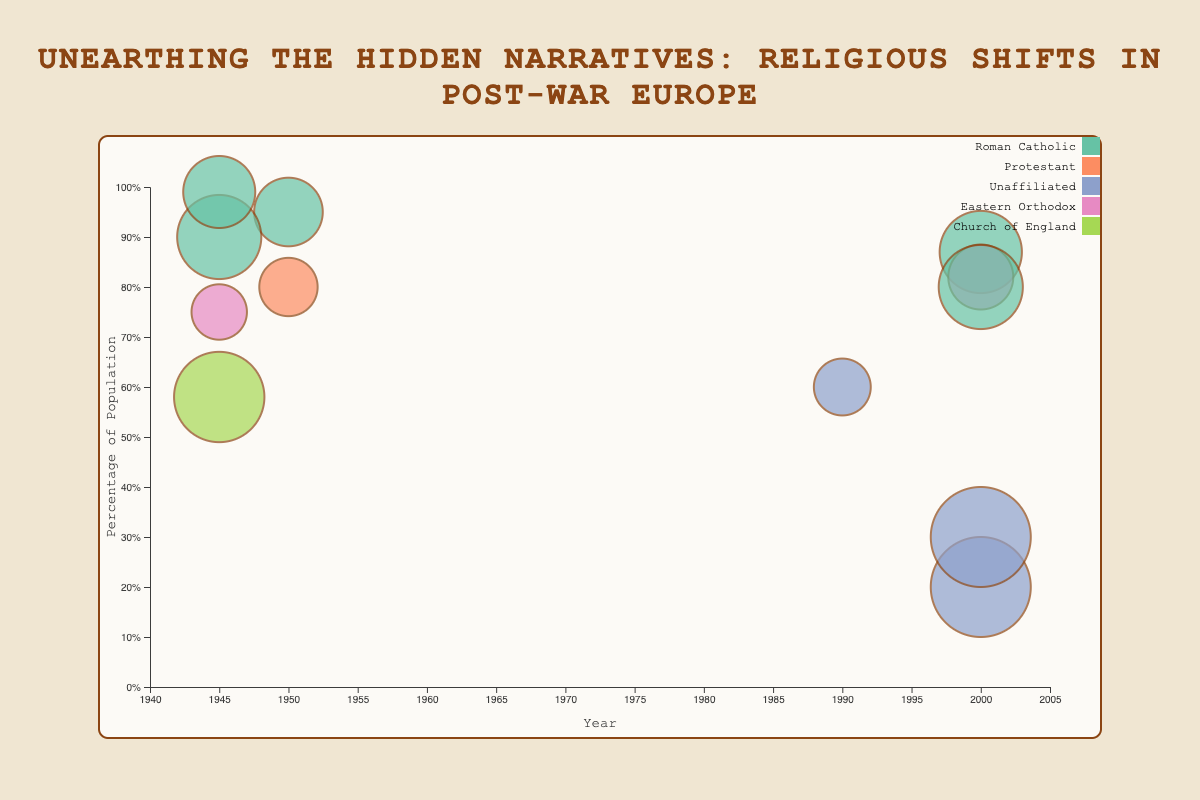What is the general trend in religious affiliation for East Germany between 1950 and 1990? Examine the bubble positions for East Germany in 1950 and 1990. In 1950, a significant Protestant population is represented by a large bubble at 80%. By 1990, a majority of the population is unaffiliated, as depicted by a large bubble at 60%. The trend shows a movement away from Protestantism towards unaffiliation.
Answer: Movement towards unaffiliation How did the percentage of Roman Catholics in Poland change from 1950 to 2000? Compare the vertical position of Poland’s bubbles for 1950 and 2000. In 1950, the bubble is positioned at around 95%, while in 2000, the bubble is positioned at around 87%. Subtracting these, the percentage decreased by 8%.
Answer: Decreased by 8% Which country experienced the highest increase in the population percentage of people unaffiliated with any religion by 2000? Identify countries with unaffiliated bubbles around 2000. Compare the percentages for East Germany and the United Kingdom. In the United Kingdom, the increase from 0% in 1945 to 20% in 2000 is noted, but in East Germany, it increased from 0% to 60%. Thus, East Germany shows a larger increase of 60%.
Answer: East Germany How does the religious affiliation change in France compare to that in Spain between 1945 and 2000? Identify the bubbles representing France and Spain. France shows a shift from 90% Roman Catholic in 1945 to 30% unaffiliated in 2000, a decrease of 60%. Spain shows a decrease from 99% Roman Catholic in 1945 to 80% in 2000. Thus, France experienced a more significant change in religious affiliation.
Answer: More significant change in France What is the average percentage change in religious affiliation for Roman Catholics in Poland, France, and Spain by 2000, compared to their earlier data points? Compute the percentage change for Poland (95% to 87%, -8%), France (90% to 30%, -60%), and Spain (99% to 80%, -19%). Add these changes: -8% + -60% + -19% = -87%. Divide by the number of countries, -87% / 3 = -29%.
Answer: -29% Which two countries showed a trend towards increasing unaffiliation from 1945/1950 to 2000? Examine bubbles representing "Unaffiliated" in the data set. The United Kingdom showed unaffiliation rising from 0% in 1945 to 20% in 2000, and East Germany showed unaffiliation rising from 0% in 1950 to 60% in 1990. These trends indicate increasing unaffiliation.
Answer: United Kingdom and East Germany What is the size of the bubble for Poland's population in 2000, and what does it represent? Examine the data point for Poland in 2000 with a population of 38 million. The bubble's size indicates the population size, which visually represents 38 million people.
Answer: Represents 38 million people How did the religious affiliation for Eastern Orthodox Christians change in Romania from 1945 to 2000? Locate Romania's bubbles for 1945 and 2000. In 1945, the bubble is at 75%, while in 2000 it is at 82%. This indicates an increase of 7%.
Answer: Increased by 7% Which country shows a stable major religious affiliation percentage from 1945/1950 to 2000? Compare the changes in religious affiliation. Romania shows a relatively stable religious affiliation with Eastern Orthodox percentages changing only slightly from 75% in 1945 to 82% in 2000.
Answer: Romania 